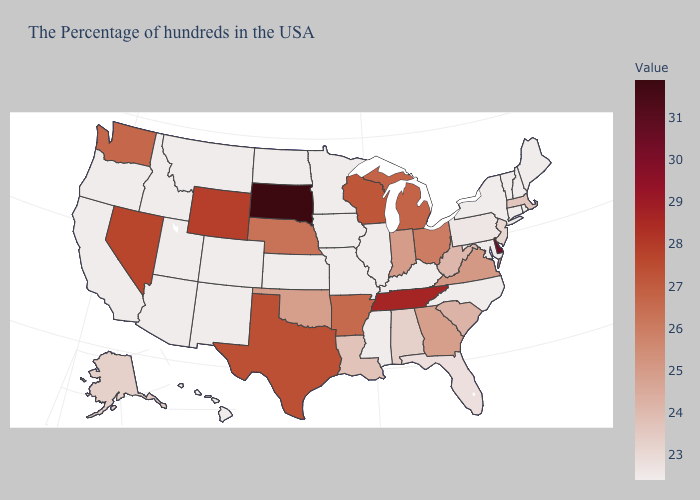Which states have the lowest value in the Northeast?
Answer briefly. Maine, Rhode Island, New Hampshire, Vermont, Connecticut, New York. Is the legend a continuous bar?
Be succinct. Yes. Among the states that border Arkansas , does Missouri have the lowest value?
Write a very short answer. Yes. Which states have the lowest value in the USA?
Concise answer only. Maine, Rhode Island, New Hampshire, Vermont, Connecticut, New York, Maryland, North Carolina, Kentucky, Illinois, Mississippi, Missouri, Minnesota, Iowa, Kansas, North Dakota, Colorado, New Mexico, Utah, Montana, Arizona, Idaho, California, Oregon, Hawaii. Among the states that border North Carolina , which have the highest value?
Keep it brief. Tennessee. Which states have the highest value in the USA?
Short answer required. South Dakota. Among the states that border Wisconsin , which have the lowest value?
Write a very short answer. Illinois, Minnesota, Iowa. Which states have the lowest value in the West?
Be succinct. Colorado, New Mexico, Utah, Montana, Arizona, Idaho, California, Oregon, Hawaii. Among the states that border Georgia , does North Carolina have the lowest value?
Concise answer only. Yes. 